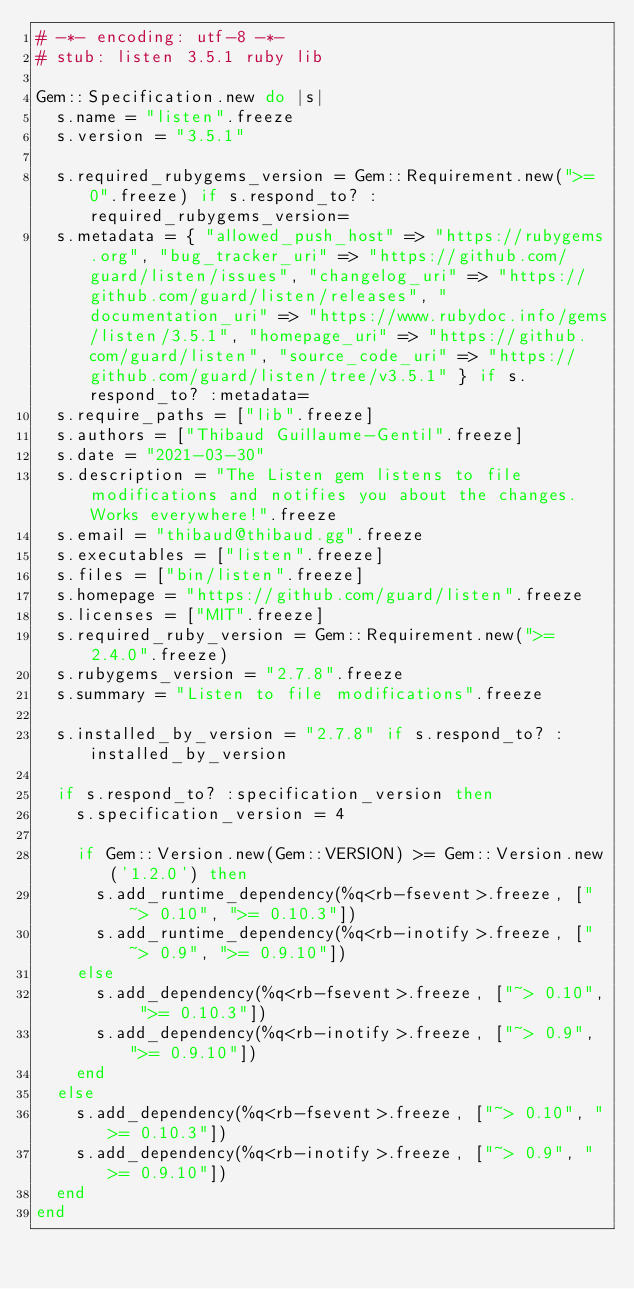<code> <loc_0><loc_0><loc_500><loc_500><_Ruby_># -*- encoding: utf-8 -*-
# stub: listen 3.5.1 ruby lib

Gem::Specification.new do |s|
  s.name = "listen".freeze
  s.version = "3.5.1"

  s.required_rubygems_version = Gem::Requirement.new(">= 0".freeze) if s.respond_to? :required_rubygems_version=
  s.metadata = { "allowed_push_host" => "https://rubygems.org", "bug_tracker_uri" => "https://github.com/guard/listen/issues", "changelog_uri" => "https://github.com/guard/listen/releases", "documentation_uri" => "https://www.rubydoc.info/gems/listen/3.5.1", "homepage_uri" => "https://github.com/guard/listen", "source_code_uri" => "https://github.com/guard/listen/tree/v3.5.1" } if s.respond_to? :metadata=
  s.require_paths = ["lib".freeze]
  s.authors = ["Thibaud Guillaume-Gentil".freeze]
  s.date = "2021-03-30"
  s.description = "The Listen gem listens to file modifications and notifies you about the changes. Works everywhere!".freeze
  s.email = "thibaud@thibaud.gg".freeze
  s.executables = ["listen".freeze]
  s.files = ["bin/listen".freeze]
  s.homepage = "https://github.com/guard/listen".freeze
  s.licenses = ["MIT".freeze]
  s.required_ruby_version = Gem::Requirement.new(">= 2.4.0".freeze)
  s.rubygems_version = "2.7.8".freeze
  s.summary = "Listen to file modifications".freeze

  s.installed_by_version = "2.7.8" if s.respond_to? :installed_by_version

  if s.respond_to? :specification_version then
    s.specification_version = 4

    if Gem::Version.new(Gem::VERSION) >= Gem::Version.new('1.2.0') then
      s.add_runtime_dependency(%q<rb-fsevent>.freeze, ["~> 0.10", ">= 0.10.3"])
      s.add_runtime_dependency(%q<rb-inotify>.freeze, ["~> 0.9", ">= 0.9.10"])
    else
      s.add_dependency(%q<rb-fsevent>.freeze, ["~> 0.10", ">= 0.10.3"])
      s.add_dependency(%q<rb-inotify>.freeze, ["~> 0.9", ">= 0.9.10"])
    end
  else
    s.add_dependency(%q<rb-fsevent>.freeze, ["~> 0.10", ">= 0.10.3"])
    s.add_dependency(%q<rb-inotify>.freeze, ["~> 0.9", ">= 0.9.10"])
  end
end
</code> 